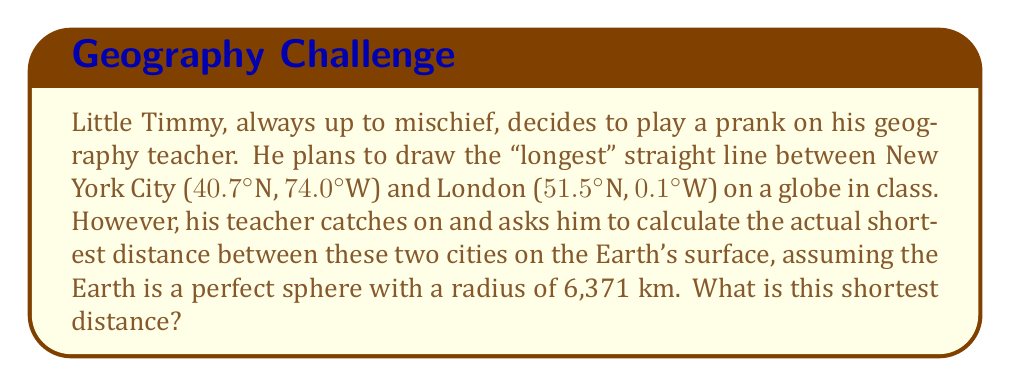Give your solution to this math problem. Let's approach this step-by-step:

1) The shortest path between two points on a sphere is along a great circle, which is the intersection of the sphere with a plane passing through the center of the sphere and both points.

2) To find the distance, we need to calculate the central angle $\theta$ between the two points and then use the arc length formula.

3) We can use the spherical law of cosines to find $\theta$:

   $$\cos(\theta) = \sin(\phi_1)\sin(\phi_2) + \cos(\phi_1)\cos(\phi_2)\cos(\Delta\lambda)$$

   Where $\phi_1$ and $\phi_2$ are the latitudes, and $\Delta\lambda$ is the difference in longitudes.

4) Convert the coordinates to radians:
   
   NYC: $\phi_1 = 40.7° \times \frac{\pi}{180} = 0.7101$ rad
        $\lambda_1 = -74.0° \times \frac{\pi}{180} = -1.2915$ rad
   
   London: $\phi_2 = 51.5° \times \frac{\pi}{180} = 0.8987$ rad
           $\lambda_2 = -0.1° \times \frac{\pi}{180} = -0.0017$ rad

5) Calculate $\Delta\lambda$:
   
   $\Delta\lambda = \lambda_2 - \lambda_1 = 1.2898$ rad

6) Apply the spherical law of cosines:

   $$\cos(\theta) = \sin(0.7101)\sin(0.8987) + \cos(0.7101)\cos(0.8987)\cos(1.2898)$$
   
   $$\cos(\theta) = 0.6504$$

7) Solve for $\theta$:
   
   $$\theta = \arccos(0.6504) = 0.8601$ rad$$

8) Calculate the arc length:
   
   $$d = R\theta = 6371 \times 0.8601 = 5478.5$ km$$
Answer: 5478.5 km 